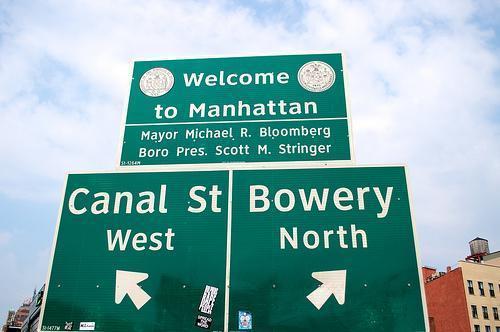How many times do you see the letter a?
Give a very brief answer. 6. 